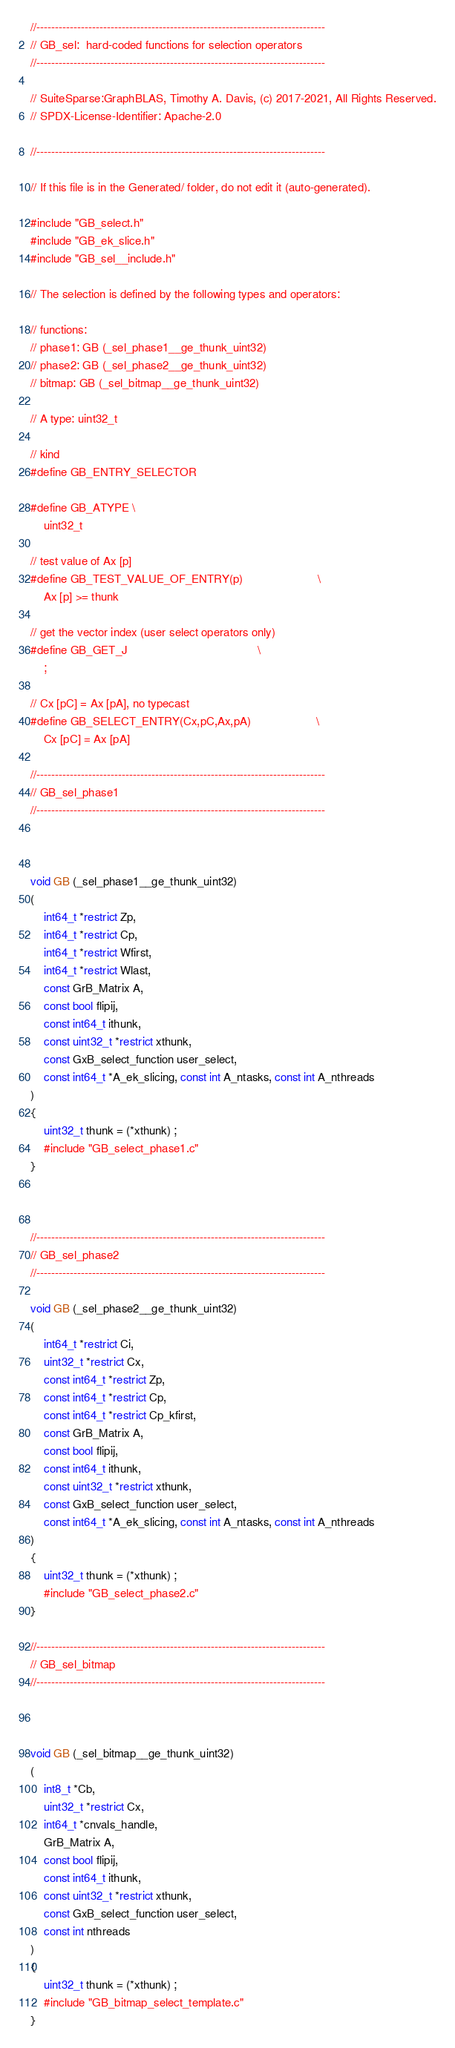Convert code to text. <code><loc_0><loc_0><loc_500><loc_500><_C_>//------------------------------------------------------------------------------
// GB_sel:  hard-coded functions for selection operators
//------------------------------------------------------------------------------

// SuiteSparse:GraphBLAS, Timothy A. Davis, (c) 2017-2021, All Rights Reserved.
// SPDX-License-Identifier: Apache-2.0

//------------------------------------------------------------------------------

// If this file is in the Generated/ folder, do not edit it (auto-generated).

#include "GB_select.h"
#include "GB_ek_slice.h"
#include "GB_sel__include.h"

// The selection is defined by the following types and operators:

// functions:
// phase1: GB (_sel_phase1__ge_thunk_uint32)
// phase2: GB (_sel_phase2__ge_thunk_uint32)
// bitmap: GB (_sel_bitmap__ge_thunk_uint32)

// A type: uint32_t

// kind
#define GB_ENTRY_SELECTOR

#define GB_ATYPE \
    uint32_t

// test value of Ax [p]
#define GB_TEST_VALUE_OF_ENTRY(p)                       \
    Ax [p] >= thunk

// get the vector index (user select operators only)
#define GB_GET_J                                        \
    ;

// Cx [pC] = Ax [pA], no typecast
#define GB_SELECT_ENTRY(Cx,pC,Ax,pA)                    \
    Cx [pC] = Ax [pA]

//------------------------------------------------------------------------------
// GB_sel_phase1
//------------------------------------------------------------------------------



void GB (_sel_phase1__ge_thunk_uint32)
(
    int64_t *restrict Zp,
    int64_t *restrict Cp,
    int64_t *restrict Wfirst,
    int64_t *restrict Wlast,
    const GrB_Matrix A,
    const bool flipij,
    const int64_t ithunk,
    const uint32_t *restrict xthunk,
    const GxB_select_function user_select,
    const int64_t *A_ek_slicing, const int A_ntasks, const int A_nthreads
)
{ 
    uint32_t thunk = (*xthunk) ;
    #include "GB_select_phase1.c"
}



//------------------------------------------------------------------------------
// GB_sel_phase2
//------------------------------------------------------------------------------

void GB (_sel_phase2__ge_thunk_uint32)
(
    int64_t *restrict Ci,
    uint32_t *restrict Cx,
    const int64_t *restrict Zp,
    const int64_t *restrict Cp,
    const int64_t *restrict Cp_kfirst,
    const GrB_Matrix A,
    const bool flipij,
    const int64_t ithunk,
    const uint32_t *restrict xthunk,
    const GxB_select_function user_select,
    const int64_t *A_ek_slicing, const int A_ntasks, const int A_nthreads
)
{ 
    uint32_t thunk = (*xthunk) ;
    #include "GB_select_phase2.c"
}

//------------------------------------------------------------------------------
// GB_sel_bitmap
//------------------------------------------------------------------------------



void GB (_sel_bitmap__ge_thunk_uint32)
(
    int8_t *Cb,
    uint32_t *restrict Cx,
    int64_t *cnvals_handle,
    GrB_Matrix A,
    const bool flipij,
    const int64_t ithunk,
    const uint32_t *restrict xthunk,
    const GxB_select_function user_select,
    const int nthreads
)
{ 
    uint32_t thunk = (*xthunk) ;
    #include "GB_bitmap_select_template.c"
}


</code> 